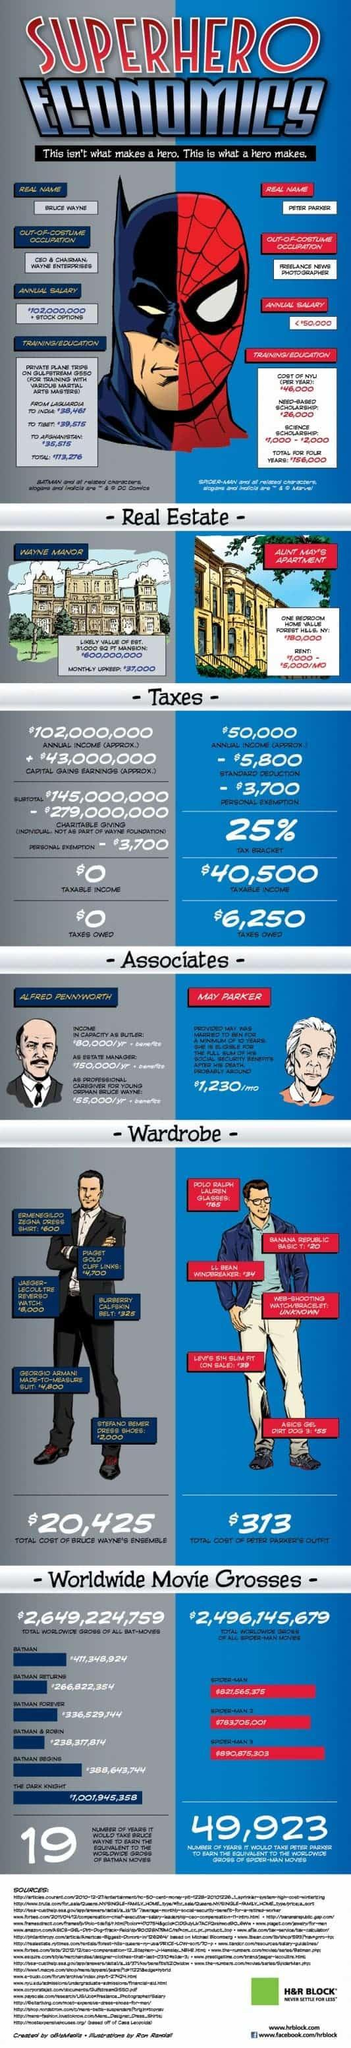How much does Alfred Pennyworth make per year?
Answer the question with a short phrase. $285,000 What is yearly net worth difference between Alfred Pennyworth and May Parker? $270,240 What is the annual income for May Parker? $14,760 What percentage of Alfred Pennyworth's salary is as Bruce Wayne's butler? 28% 